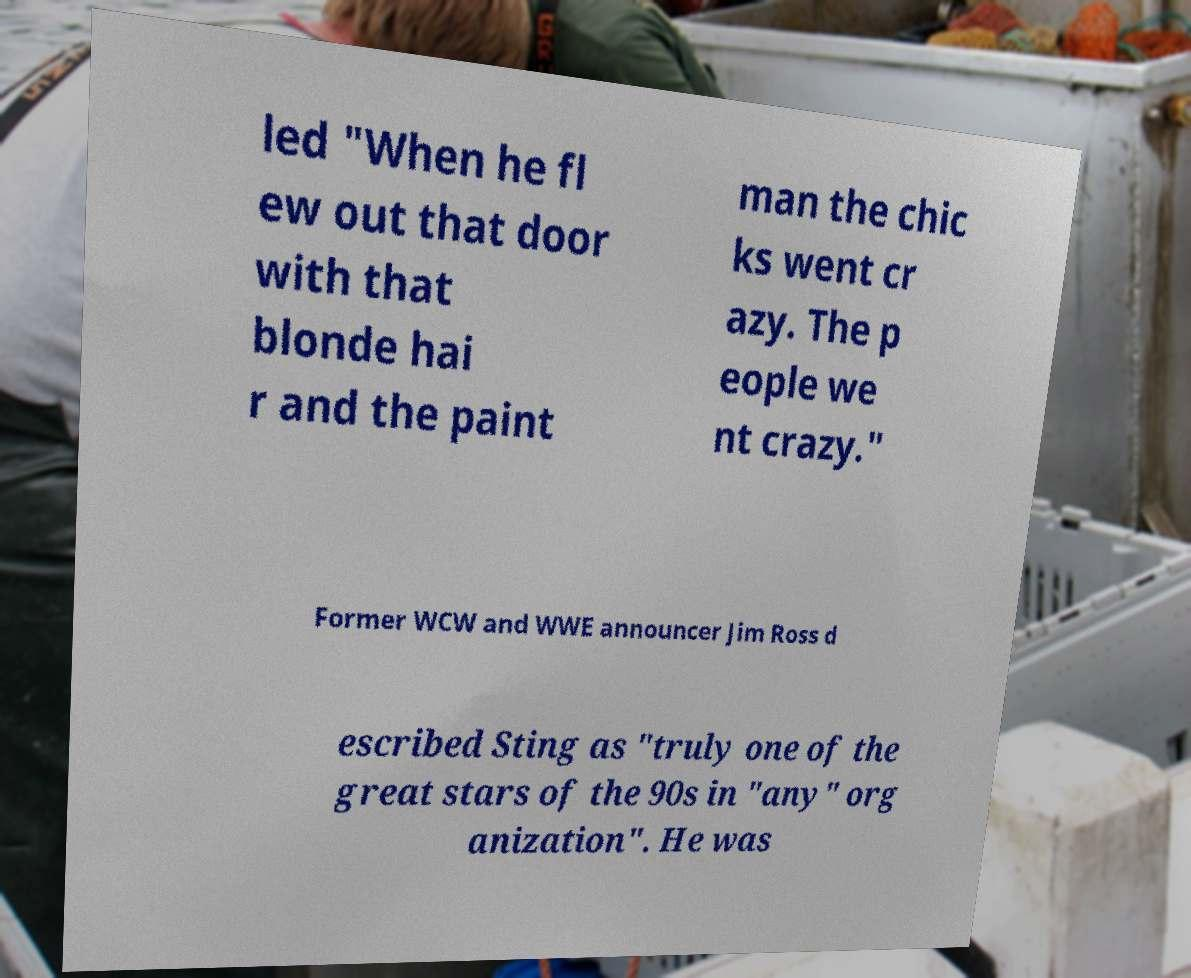Could you extract and type out the text from this image? led "When he fl ew out that door with that blonde hai r and the paint man the chic ks went cr azy. The p eople we nt crazy." Former WCW and WWE announcer Jim Ross d escribed Sting as "truly one of the great stars of the 90s in "any" org anization". He was 